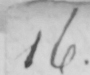Please provide the text content of this handwritten line. 16 . 